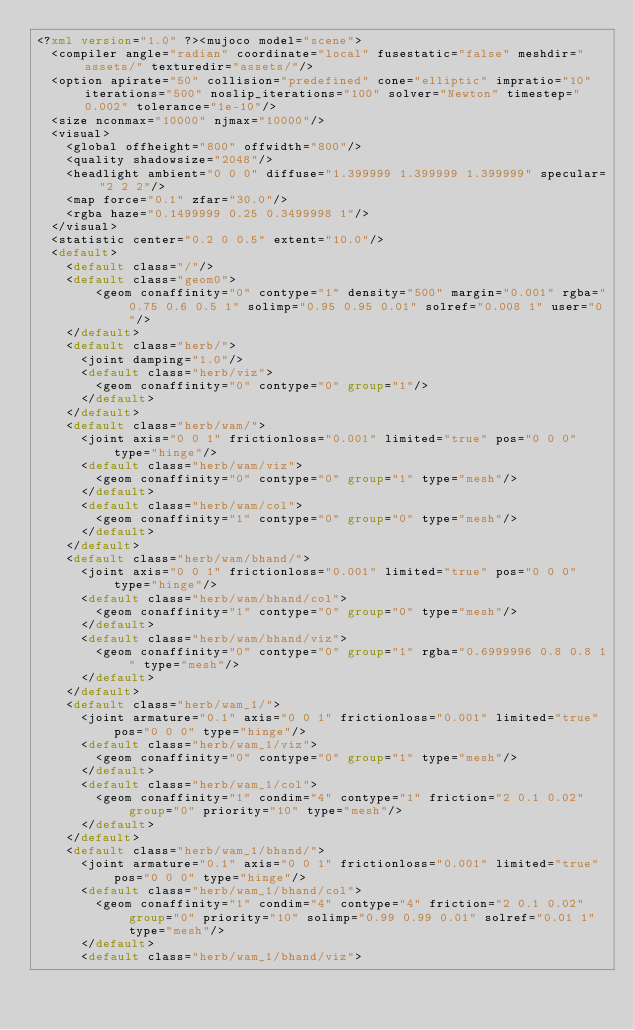<code> <loc_0><loc_0><loc_500><loc_500><_XML_><?xml version="1.0" ?><mujoco model="scene">
  <compiler angle="radian" coordinate="local" fusestatic="false" meshdir="assets/" texturedir="assets/"/>
  <option apirate="50" collision="predefined" cone="elliptic" impratio="10" iterations="500" noslip_iterations="100" solver="Newton" timestep="0.002" tolerance="1e-10"/>
  <size nconmax="10000" njmax="10000"/>
  <visual>
    <global offheight="800" offwidth="800"/>
    <quality shadowsize="2048"/>
    <headlight ambient="0 0 0" diffuse="1.399999 1.399999 1.399999" specular="2 2 2"/>
    <map force="0.1" zfar="30.0"/>
    <rgba haze="0.1499999 0.25 0.3499998 1"/>
  </visual>
  <statistic center="0.2 0 0.5" extent="10.0"/>
  <default>
    <default class="/"/>
    <default class="geom0">
        <geom conaffinity="0" contype="1" density="500" margin="0.001" rgba="0.75 0.6 0.5 1" solimp="0.95 0.95 0.01" solref="0.008 1" user="0"/>
    </default>
    <default class="herb/">
      <joint damping="1.0"/>
      <default class="herb/viz">
        <geom conaffinity="0" contype="0" group="1"/>
      </default>
    </default>
    <default class="herb/wam/">
      <joint axis="0 0 1" frictionloss="0.001" limited="true" pos="0 0 0" type="hinge"/>
      <default class="herb/wam/viz">
        <geom conaffinity="0" contype="0" group="1" type="mesh"/>
      </default>
      <default class="herb/wam/col">
        <geom conaffinity="1" contype="0" group="0" type="mesh"/>
      </default>
    </default>
    <default class="herb/wam/bhand/">
      <joint axis="0 0 1" frictionloss="0.001" limited="true" pos="0 0 0" type="hinge"/>
      <default class="herb/wam/bhand/col">
        <geom conaffinity="1" contype="0" group="0" type="mesh"/>
      </default>
      <default class="herb/wam/bhand/viz">
        <geom conaffinity="0" contype="0" group="1" rgba="0.6999996 0.8 0.8 1" type="mesh"/>
      </default>
    </default>
    <default class="herb/wam_1/">
      <joint armature="0.1" axis="0 0 1" frictionloss="0.001" limited="true" pos="0 0 0" type="hinge"/>
      <default class="herb/wam_1/viz">
        <geom conaffinity="0" contype="0" group="1" type="mesh"/>
      </default>
      <default class="herb/wam_1/col">
        <geom conaffinity="1" condim="4" contype="1" friction="2 0.1 0.02" group="0" priority="10" type="mesh"/>
      </default>
    </default>
    <default class="herb/wam_1/bhand/">
      <joint armature="0.1" axis="0 0 1" frictionloss="0.001" limited="true" pos="0 0 0" type="hinge"/>
      <default class="herb/wam_1/bhand/col">
        <geom conaffinity="1" condim="4" contype="4" friction="2 0.1 0.02" group="0" priority="10" solimp="0.99 0.99 0.01" solref="0.01 1" type="mesh"/>
      </default> 
      <default class="herb/wam_1/bhand/viz"></code> 